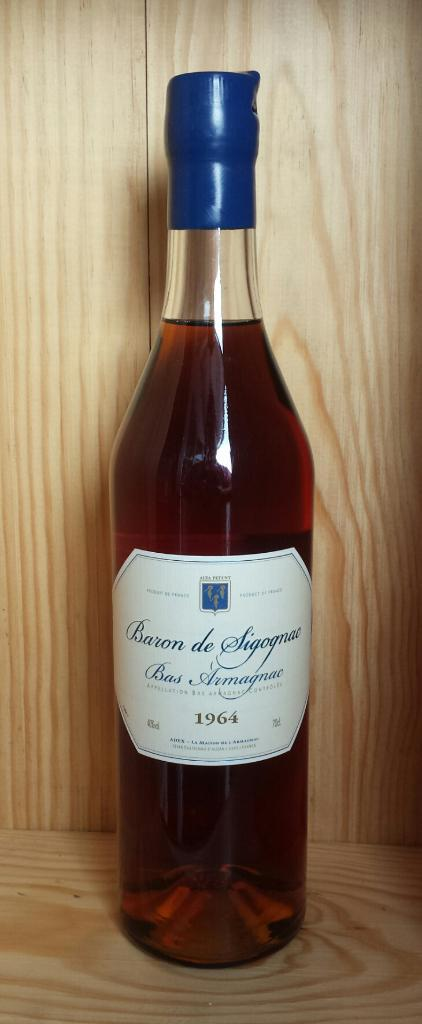<image>
Present a compact description of the photo's key features. A bottle of Baron de Sigognac sits against a wooden shelf 